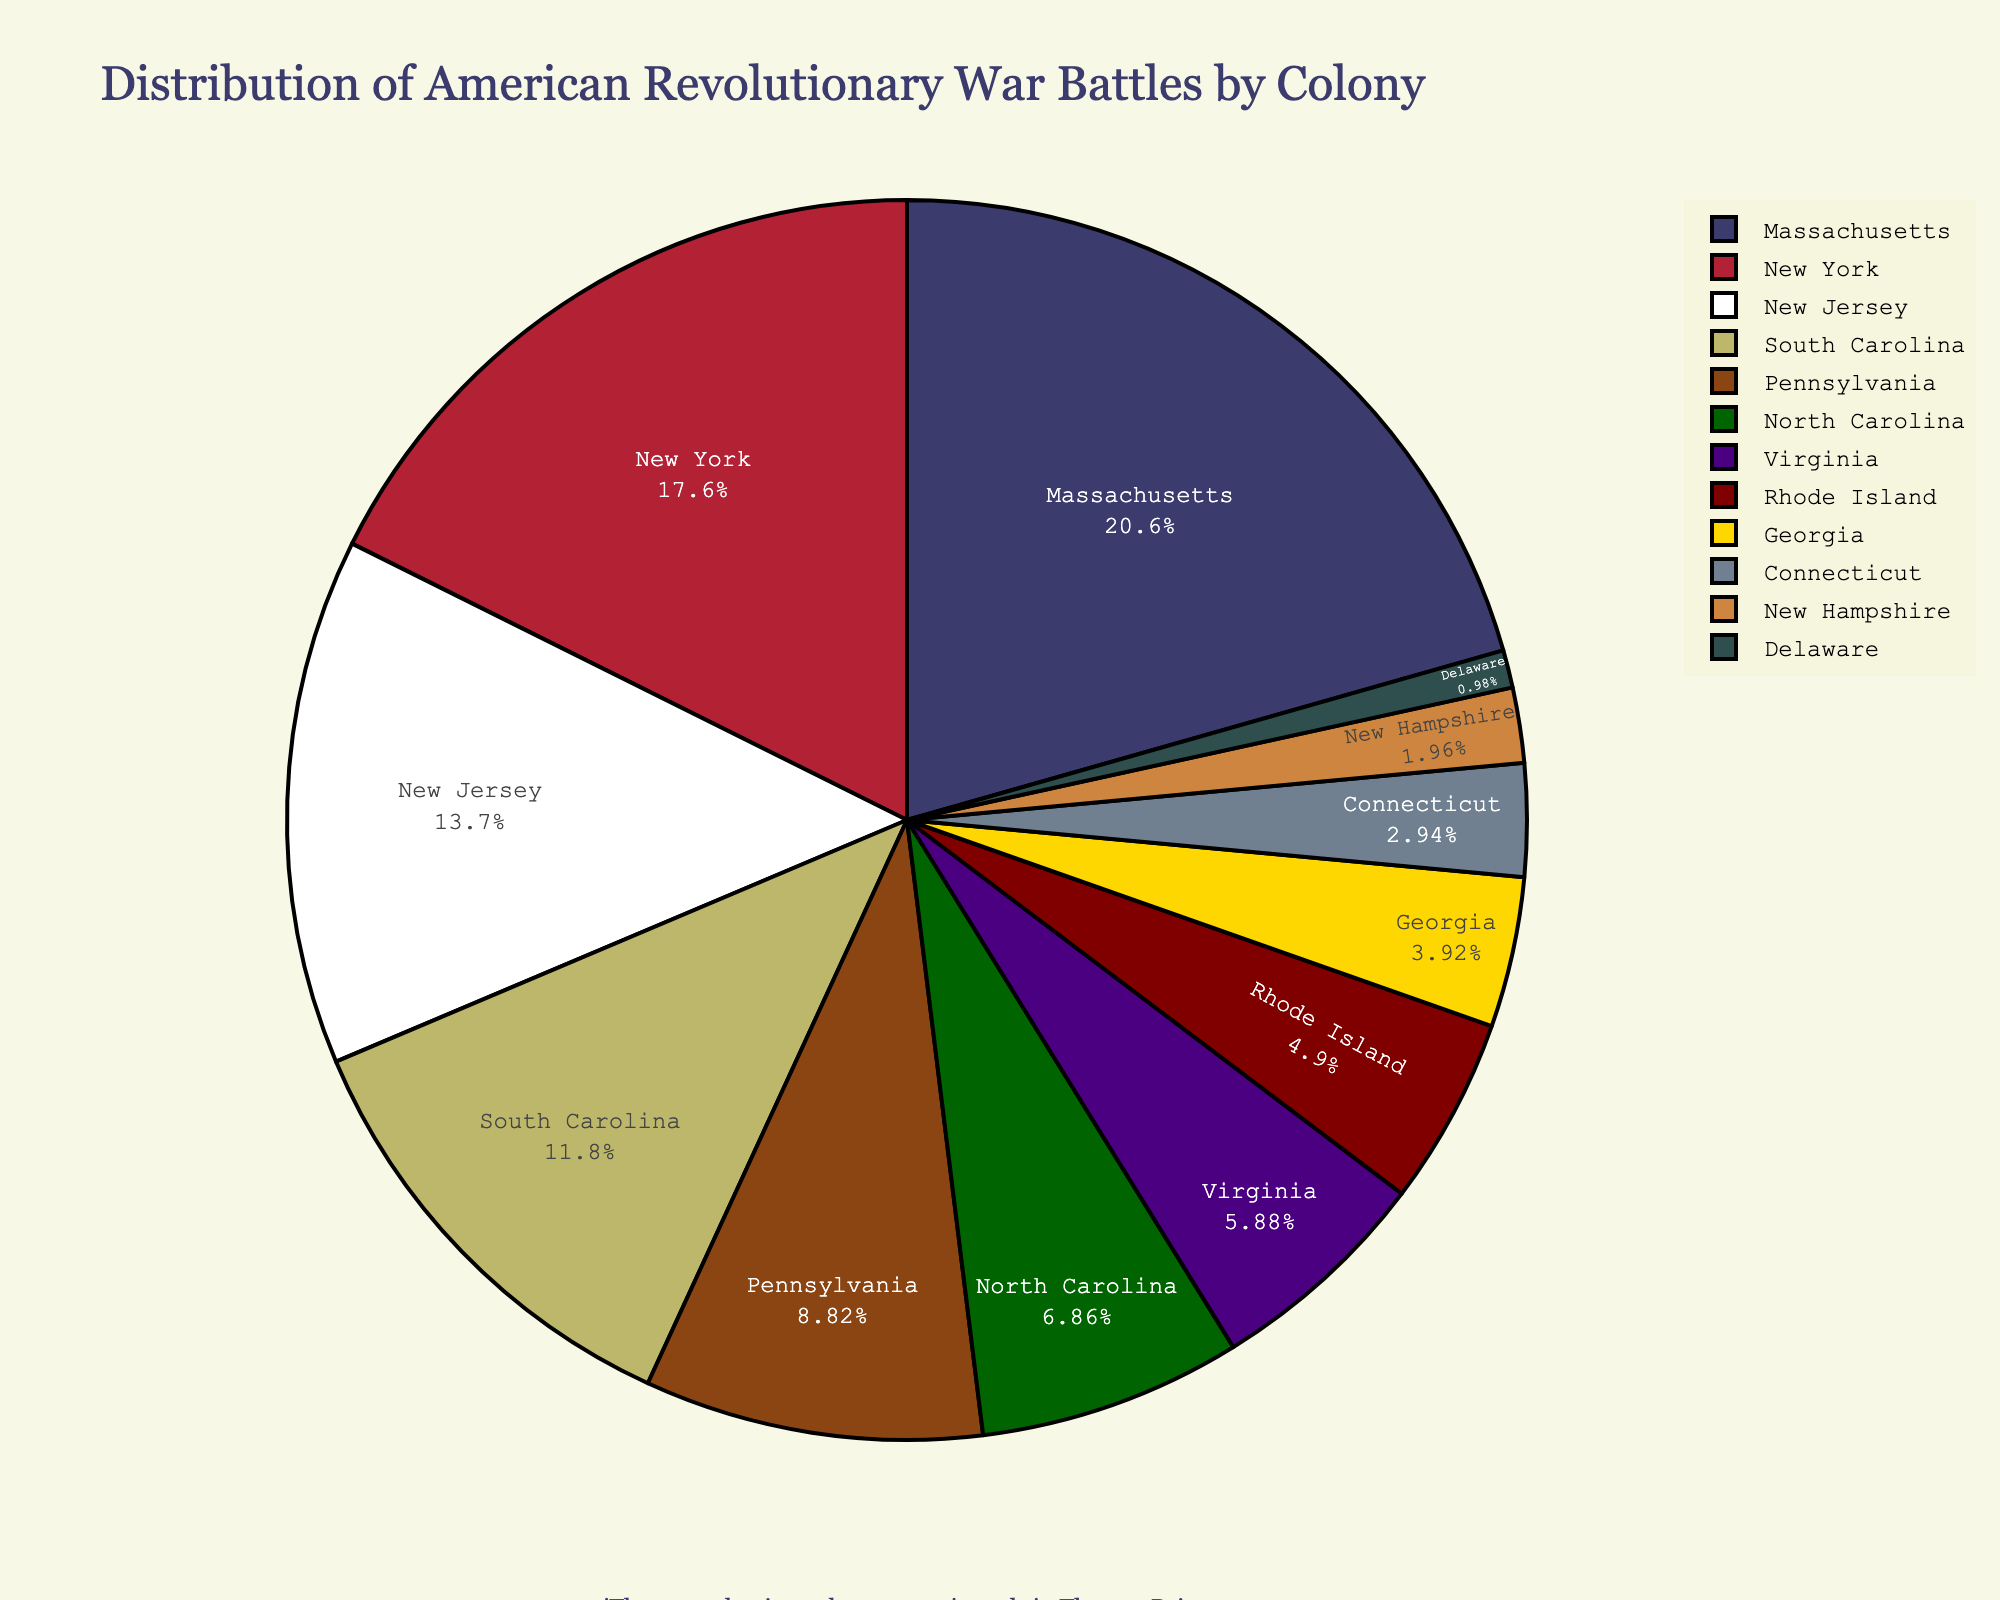What is the colony with the largest number of battles? To find the colony with the largest number of battles, look for the one with the largest segment in the pie chart. The largest segment corresponds to Massachusetts.
Answer: Massachusetts Which colony has fewer battles: Pennsylvania or South Carolina? To determine which colony has fewer battles, compare their segments in the pie chart. Pennsylvania has a smaller segment than South Carolina.
Answer: Pennsylvania What is the total number of battles in New England colonies (Massachusetts, Connecticut, Rhode Island, New Hampshire)? Sum the battles in Massachusetts (21), Connecticut (3), Rhode Island (5), and New Hampshire (2). The total is 21 + 3 + 5 + 2 = 31.
Answer: 31 What fraction of battles occurred in New York compared to New Jersey? Divide the number of battles in New York (18) by the number of battles in New Jersey (14). The fraction is 18/14, which simplifies to 9/7.
Answer: 9/7 Which colony's segment is represented in a color that is historically associated with the military? The color associated with the military is often green. North Carolina's segment is depicted in a green color, inspired by historical American colors.
Answer: North Carolina 